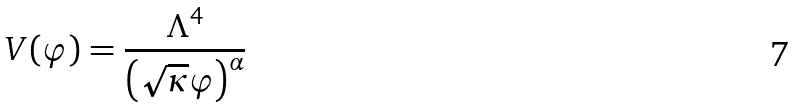Convert formula to latex. <formula><loc_0><loc_0><loc_500><loc_500>V ( \varphi ) = \frac { \Lambda ^ { 4 } } { \left ( \sqrt { \kappa } \varphi \right ) ^ { \alpha } }</formula> 